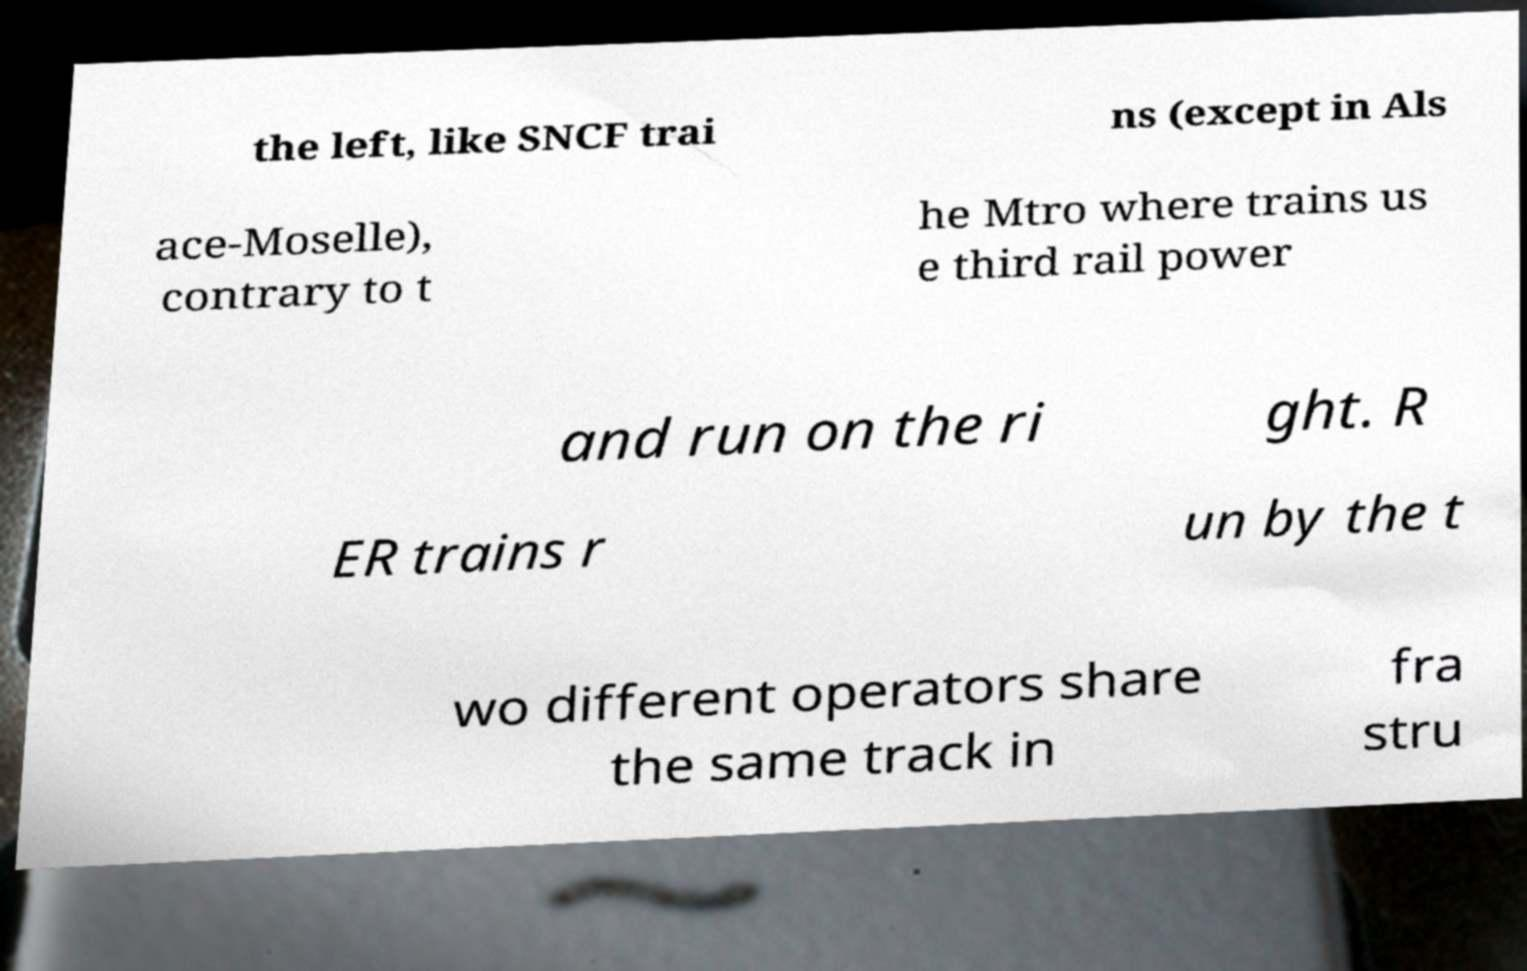Could you extract and type out the text from this image? the left, like SNCF trai ns (except in Als ace-Moselle), contrary to t he Mtro where trains us e third rail power and run on the ri ght. R ER trains r un by the t wo different operators share the same track in fra stru 